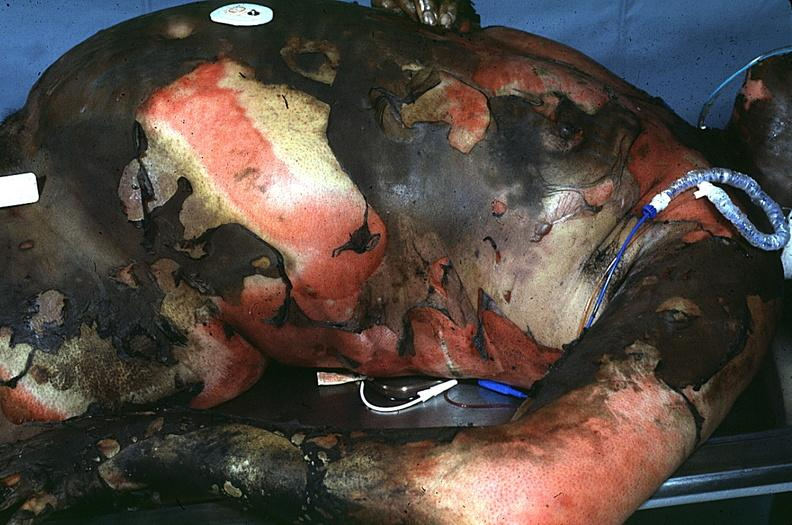where is this?
Answer the question using a single word or phrase. Skin 